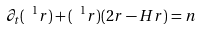Convert formula to latex. <formula><loc_0><loc_0><loc_500><loc_500>\partial _ { t } ( \ ^ { 1 } r ) + ( \ ^ { 1 } r ) ( 2 r - H r ) = n</formula> 